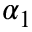<formula> <loc_0><loc_0><loc_500><loc_500>\alpha _ { 1 }</formula> 